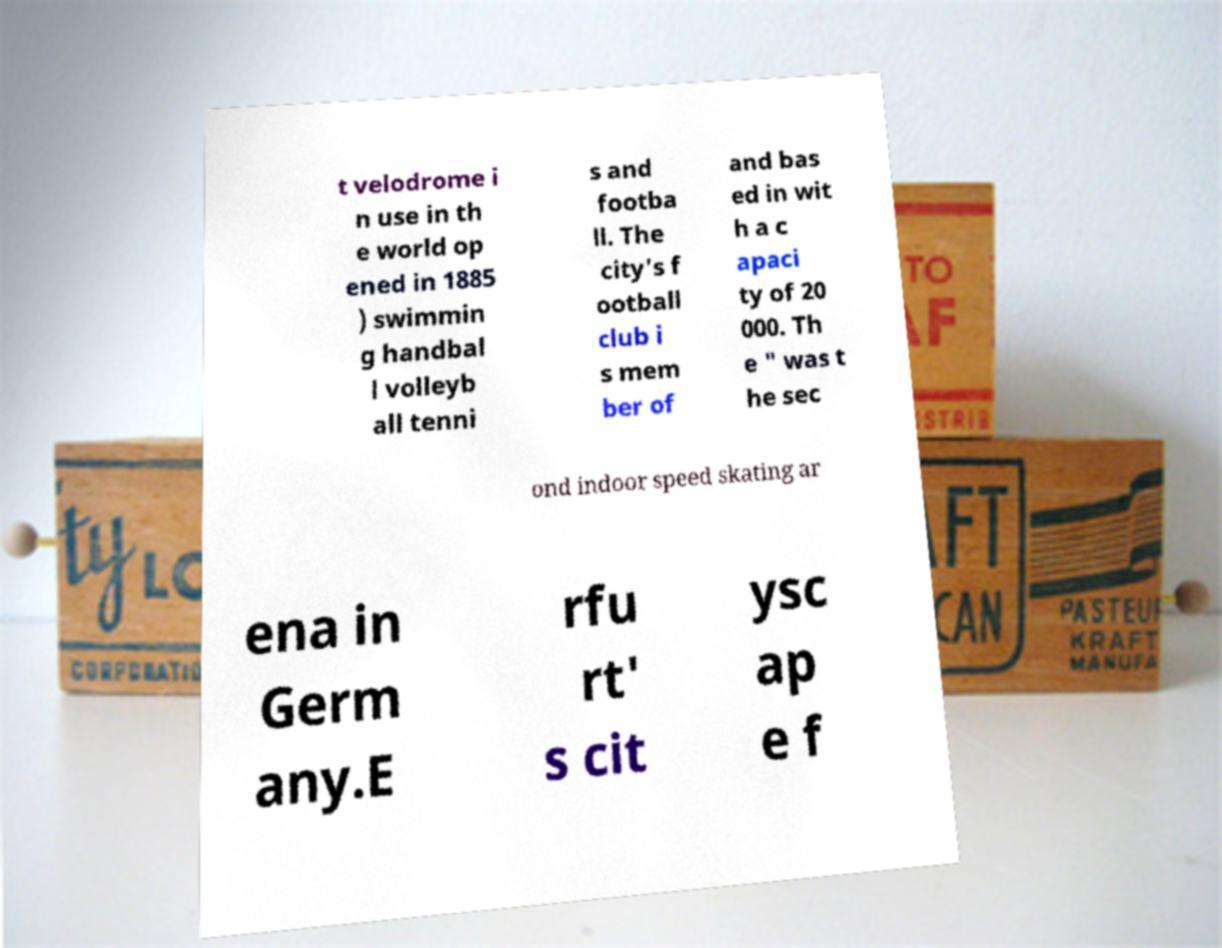Please read and relay the text visible in this image. What does it say? t velodrome i n use in th e world op ened in 1885 ) swimmin g handbal l volleyb all tenni s and footba ll. The city's f ootball club i s mem ber of and bas ed in wit h a c apaci ty of 20 000. Th e " was t he sec ond indoor speed skating ar ena in Germ any.E rfu rt' s cit ysc ap e f 